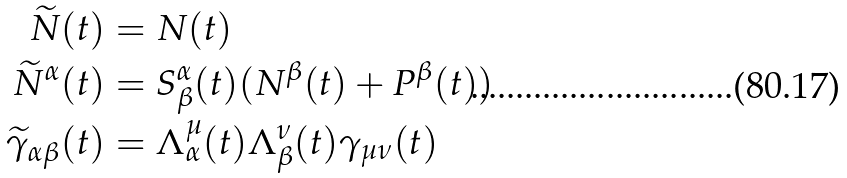<formula> <loc_0><loc_0><loc_500><loc_500>\widetilde { N } ( t ) & = N ( t ) \\ \widetilde { N } ^ { \alpha } ( t ) & = S ^ { \alpha } _ { \beta } ( t ) ( N ^ { \beta } ( t ) + P ^ { \beta } ( t ) ) \\ \widetilde { \gamma } _ { \alpha \beta } ( t ) & = \Lambda ^ { \mu } _ { \alpha } ( t ) \Lambda ^ { \nu } _ { \beta } ( t ) \gamma _ { \mu \nu } ( t )</formula> 